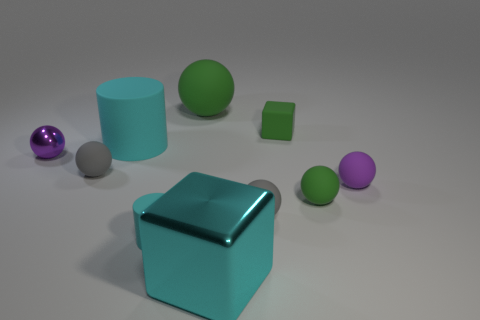The tiny purple object that is made of the same material as the large green thing is what shape?
Offer a very short reply. Sphere. Are there more small green spheres in front of the tiny cube than yellow rubber cubes?
Keep it short and to the point. Yes. How many big spheres are the same color as the small block?
Give a very brief answer. 1. What number of other objects are the same color as the big matte sphere?
Provide a short and direct response. 2. Are there more yellow blocks than cyan shiny blocks?
Ensure brevity in your answer.  No. What is the large green sphere made of?
Ensure brevity in your answer.  Rubber. There is a cyan shiny object in front of the green block; does it have the same size as the small purple rubber object?
Make the answer very short. No. How big is the metallic object to the right of the large ball?
Make the answer very short. Large. What number of small gray spheres are there?
Offer a very short reply. 2. Do the large metallic object and the large matte cylinder have the same color?
Make the answer very short. Yes. 